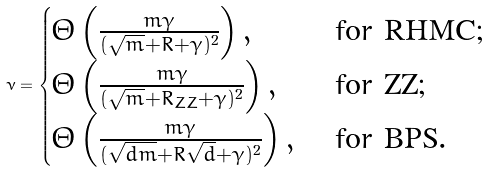<formula> <loc_0><loc_0><loc_500><loc_500>\nu = \begin{cases} \Theta \left ( \frac { m \gamma } { ( \sqrt { m } + R + \gamma ) ^ { 2 } } \right ) , & \text { for     RHMC;} \\ \Theta \left ( \frac { m \gamma } { ( \sqrt { m } + R _ { Z Z } + \gamma ) ^ { 2 } } \right ) , & \text { for ZZ;} \\ \Theta \left ( \frac { m \gamma } { ( \sqrt { d m } + R \sqrt { d } + \gamma ) ^ { 2 } } \right ) , & \text { for BPS} . \end{cases}</formula> 